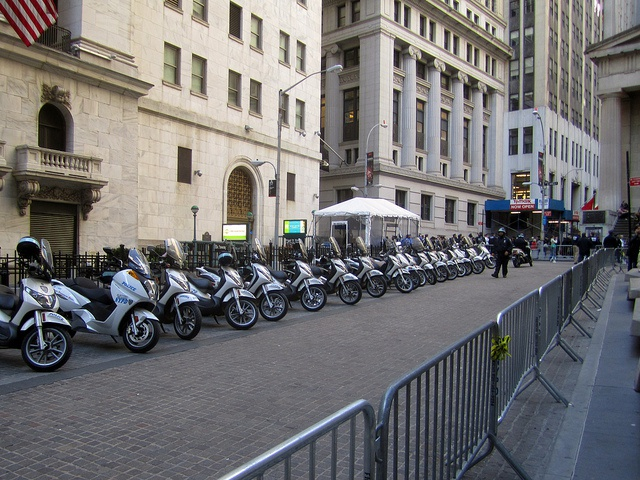Describe the objects in this image and their specific colors. I can see motorcycle in gray, black, and darkgray tones, motorcycle in gray, black, navy, and darkgray tones, motorcycle in gray, black, and darkgray tones, motorcycle in gray, black, and darkgray tones, and motorcycle in gray, black, darkgray, and lightgray tones in this image. 